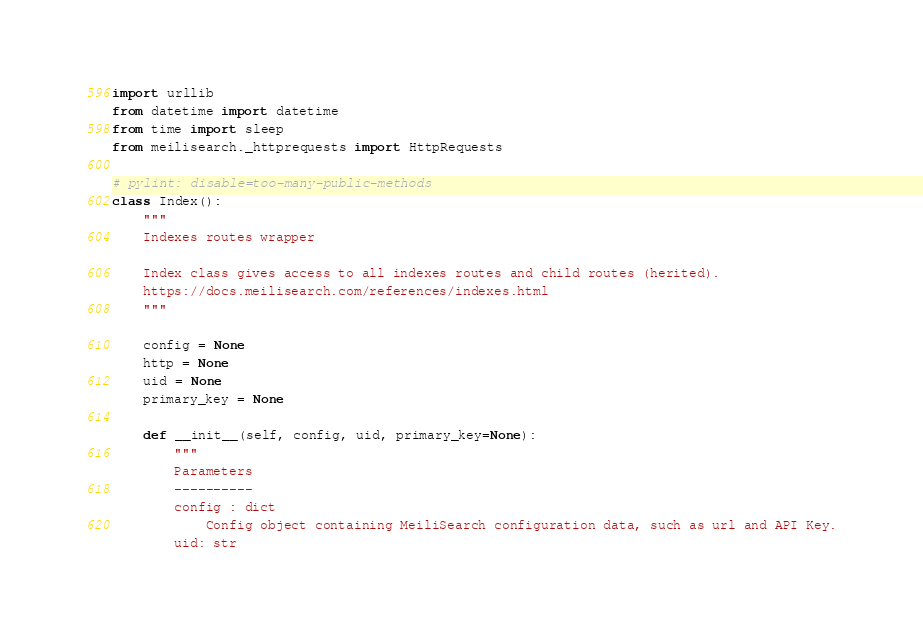Convert code to text. <code><loc_0><loc_0><loc_500><loc_500><_Python_>import urllib
from datetime import datetime
from time import sleep
from meilisearch._httprequests import HttpRequests

# pylint: disable=too-many-public-methods
class Index():
    """
    Indexes routes wrapper

    Index class gives access to all indexes routes and child routes (herited).
    https://docs.meilisearch.com/references/indexes.html
    """

    config = None
    http = None
    uid = None
    primary_key = None

    def __init__(self, config, uid, primary_key=None):
        """
        Parameters
        ----------
        config : dict
            Config object containing MeiliSearch configuration data, such as url and API Key.
        uid: str</code> 